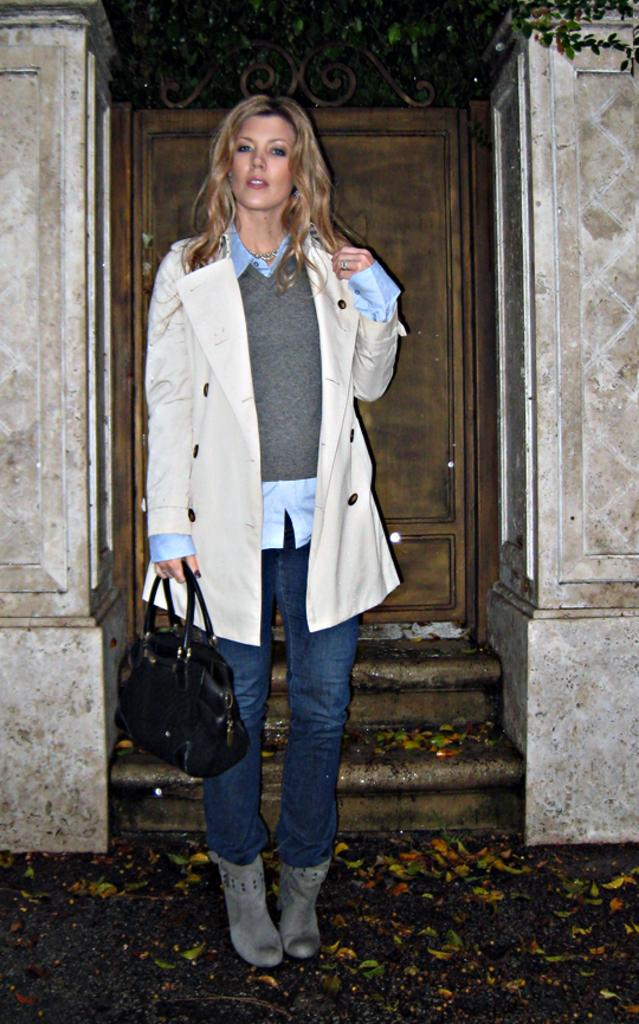What type of scene is depicted in the image? The image is of an outdoor scene. Can you describe the main subject in the image? There is a woman in the center of the image. What is the woman holding in the image? The woman is holding a black purse. What is the woman's posture in the image? The woman is standing. What architectural features can be seen in the background of the image? There is a door, stairs, and walls in the background of the image. What type of learning is the woman engaged in while holding the soap in the image? There is no soap present in the image, and the woman is not engaged in any learning activities. 